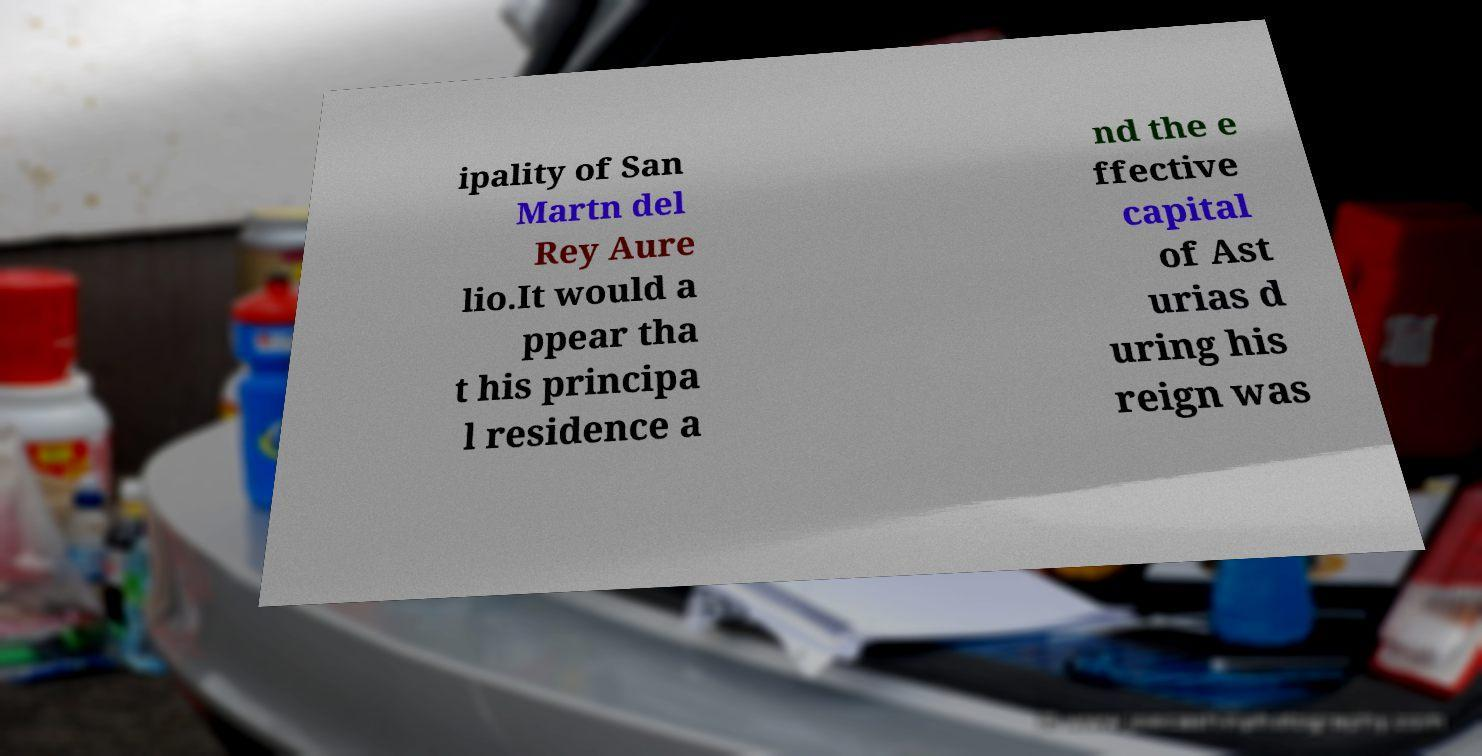Could you extract and type out the text from this image? ipality of San Martn del Rey Aure lio.It would a ppear tha t his principa l residence a nd the e ffective capital of Ast urias d uring his reign was 